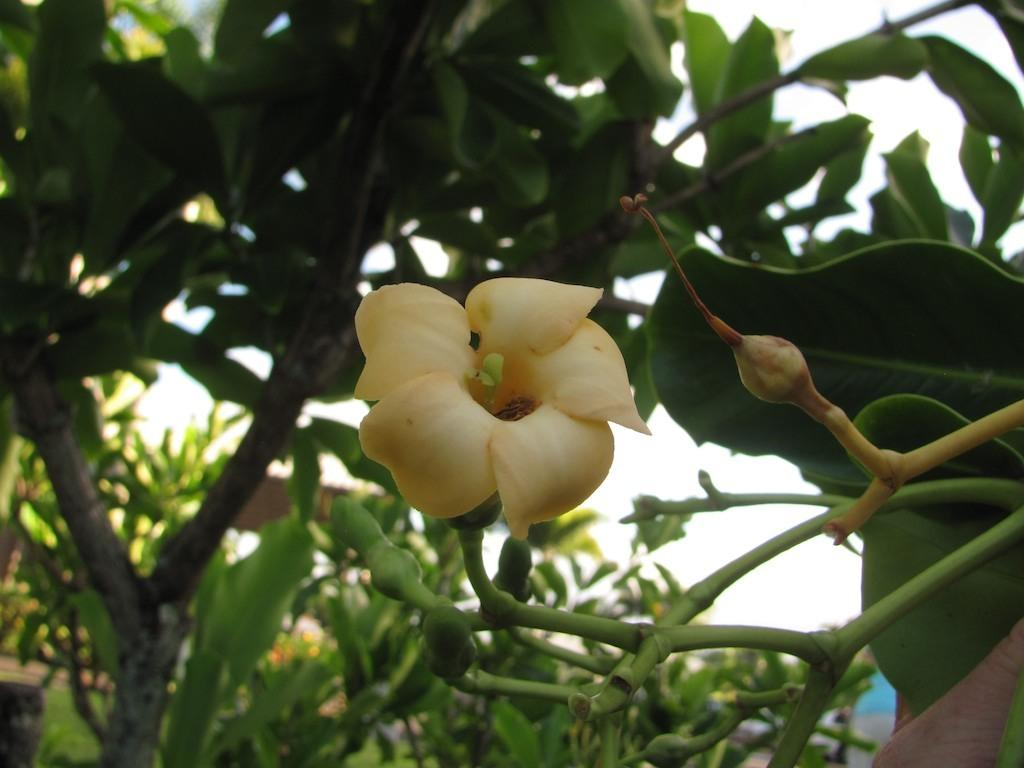What type of flower can be seen in the image? There is a cream flower in the image. Can you describe the stage of development of the other flower in the image? There is a flower bud in the image. What do the flowers belong to? The flowers belong to a plant. What can be seen in the background of the image? There are trees visible in the background of the image. What type of coat is the horse wearing in the image? There is no horse or coat present in the image. 